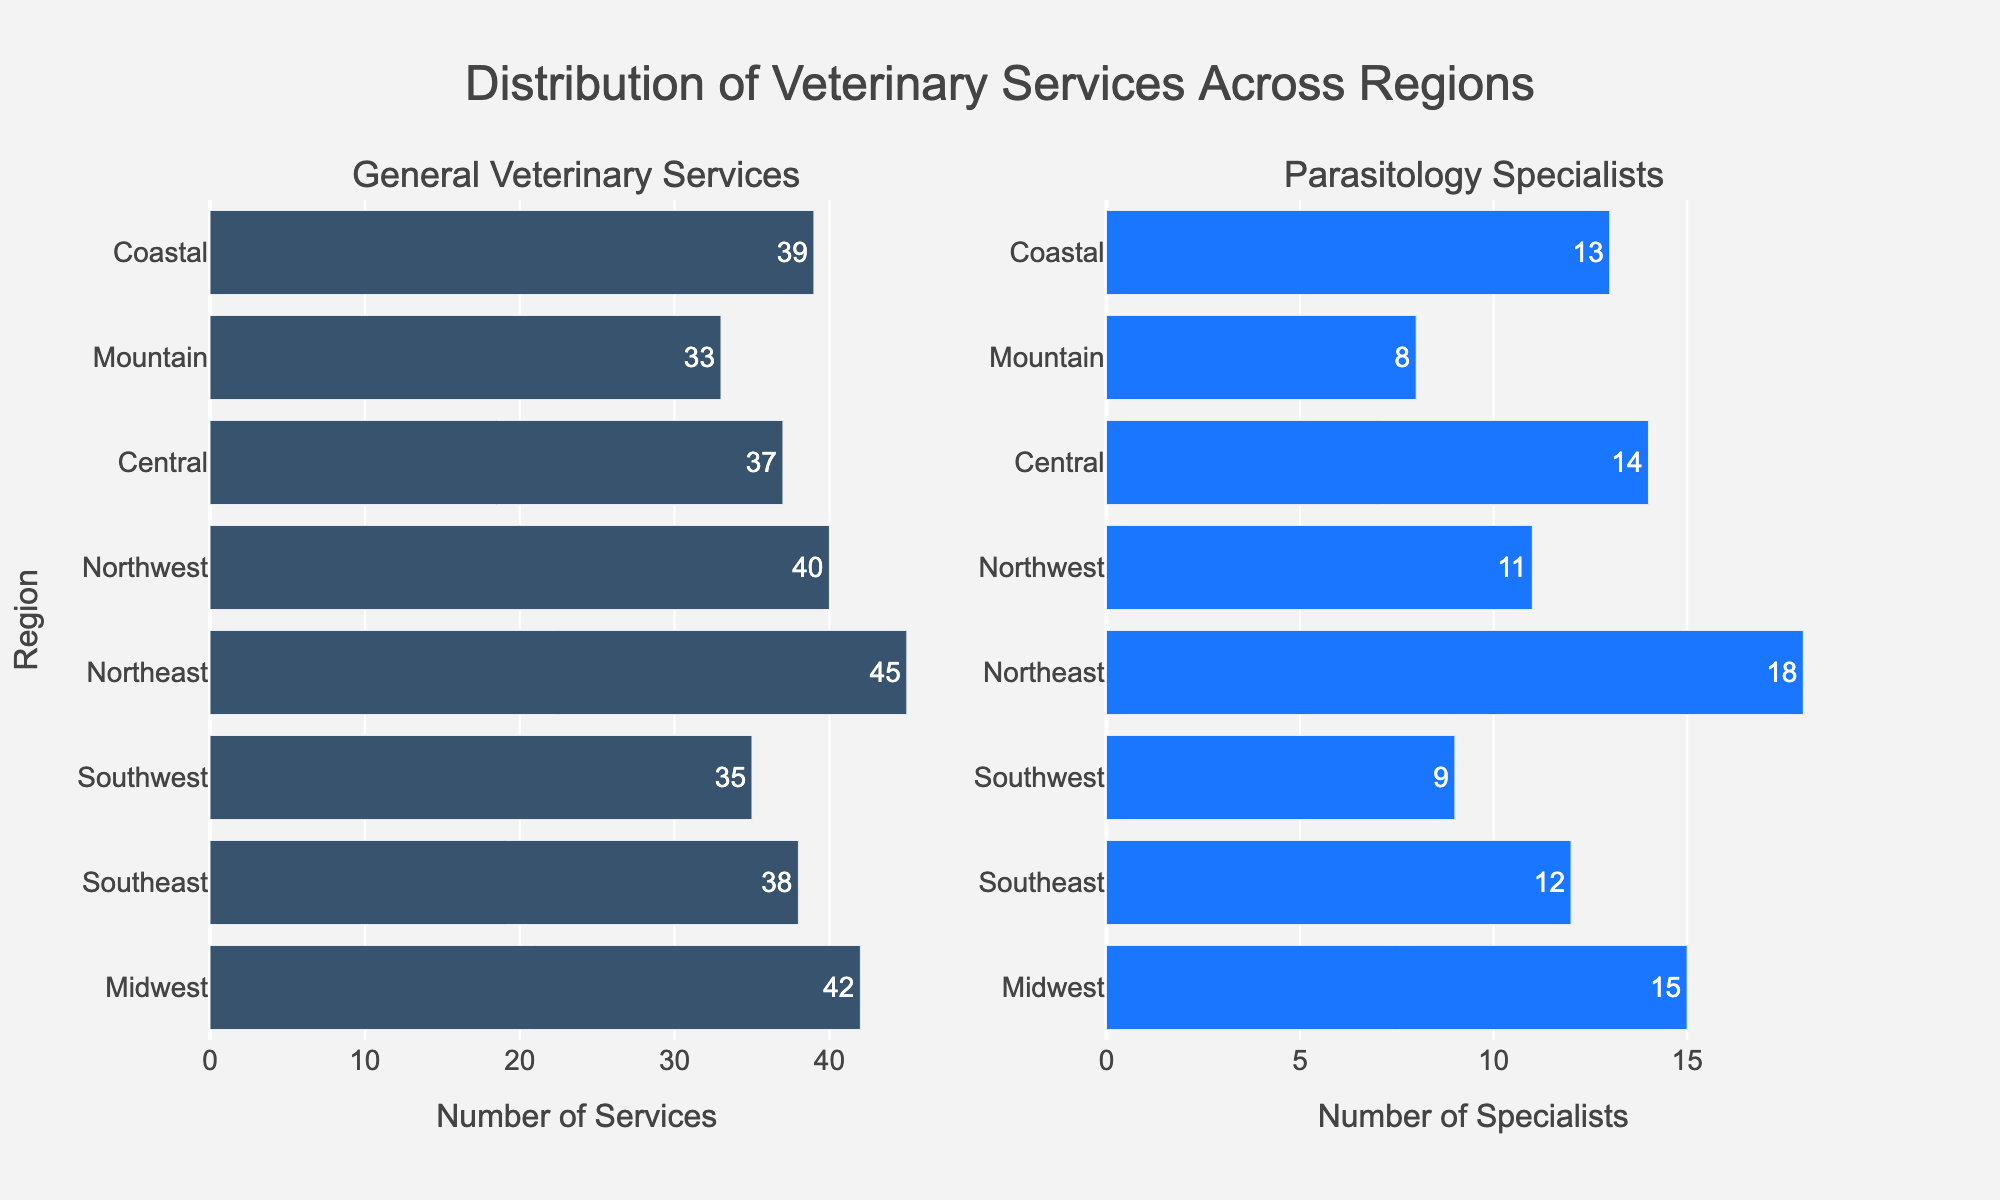Which region has the highest number of general veterinary services? Look at the bar for each region in the "General Veterinary Services" subplot. The Northeast region has the longest bar, indicating it has the highest number.
Answer: Northeast Which region has the least number of parasitology specialists? Look at the bar for each region in the "Parasitology Specialists" subplot. The Mountain region has the shortest bar, indicating it has the least number.
Answer: Mountain How many regions have more than 40 general veterinary services? Count the bars that extend beyond 40 in the "General Veterinary Services" subplot. These regions are Midwest, Northeast, and Northwest.
Answer: 3 Is there any region where the number of parasitology specialists exceeds 15? Look for bars that extend beyond the value of 15 in the "Parasitology Specialists" subplot. The Northeast region has 18 specialists, which exceeds 15.
Answer: Yes What is the average number of general veterinary services across all regions? Add up the number of general veterinary services in all regions (42 + 38 + 35 + 45 + 40 + 37 + 33 + 39) and divide by the number of regions (8). The sum is 309, so the average is 309/8.
Answer: 38.625 Which region has a greater difference between general veterinary services and parasitology specialists, Southeast or Central? Calculate the difference for both regions. Southeast: 38 - 12 = 26, Central: 37 - 14 = 23. The difference is greater in Southeast.
Answer: Southeast How many regions have 10 or fewer parasitology specialists? Count the bars that are at or below 10 in the "Parasitology Specialists" subplot. These regions are Southwest and Mountain.
Answer: 2 Which region has the highest combined total of general veterinary services and parasitology specialists? Calculate the combined total for each region and compare. The highest combined total is found in Northeast (45 + 18 = 63).
Answer: Northeast 